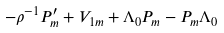Convert formula to latex. <formula><loc_0><loc_0><loc_500><loc_500>- \rho ^ { - 1 } P _ { m } ^ { \prime } + V _ { 1 m } + \Lambda _ { 0 } P _ { m } - P _ { m } \Lambda _ { 0 }</formula> 